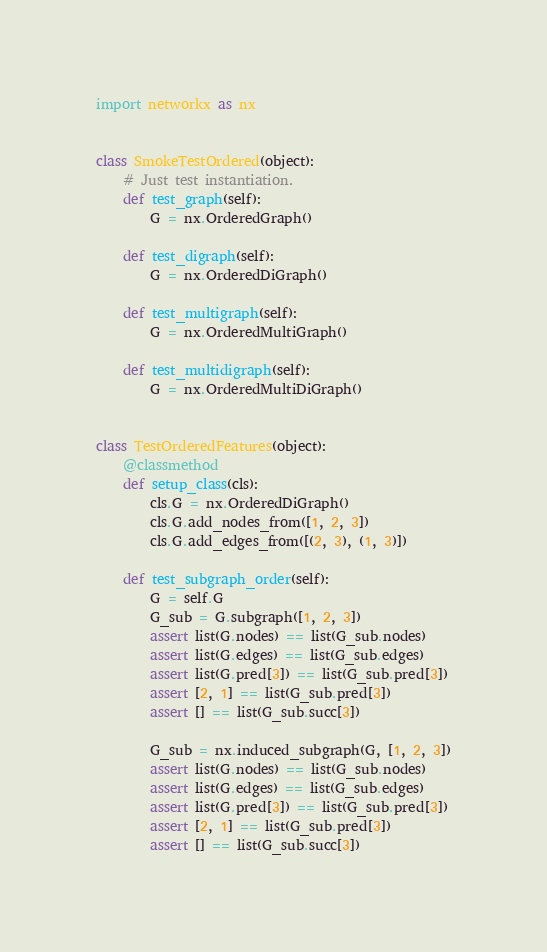<code> <loc_0><loc_0><loc_500><loc_500><_Python_>import networkx as nx


class SmokeTestOrdered(object):
    # Just test instantiation.
    def test_graph(self):
        G = nx.OrderedGraph()

    def test_digraph(self):
        G = nx.OrderedDiGraph()

    def test_multigraph(self):
        G = nx.OrderedMultiGraph()

    def test_multidigraph(self):
        G = nx.OrderedMultiDiGraph()


class TestOrderedFeatures(object):
    @classmethod
    def setup_class(cls):
        cls.G = nx.OrderedDiGraph()
        cls.G.add_nodes_from([1, 2, 3])
        cls.G.add_edges_from([(2, 3), (1, 3)])

    def test_subgraph_order(self):
        G = self.G
        G_sub = G.subgraph([1, 2, 3])
        assert list(G.nodes) == list(G_sub.nodes)
        assert list(G.edges) == list(G_sub.edges)
        assert list(G.pred[3]) == list(G_sub.pred[3])
        assert [2, 1] == list(G_sub.pred[3])
        assert [] == list(G_sub.succ[3])

        G_sub = nx.induced_subgraph(G, [1, 2, 3])
        assert list(G.nodes) == list(G_sub.nodes)
        assert list(G.edges) == list(G_sub.edges)
        assert list(G.pred[3]) == list(G_sub.pred[3])
        assert [2, 1] == list(G_sub.pred[3])
        assert [] == list(G_sub.succ[3])
</code> 